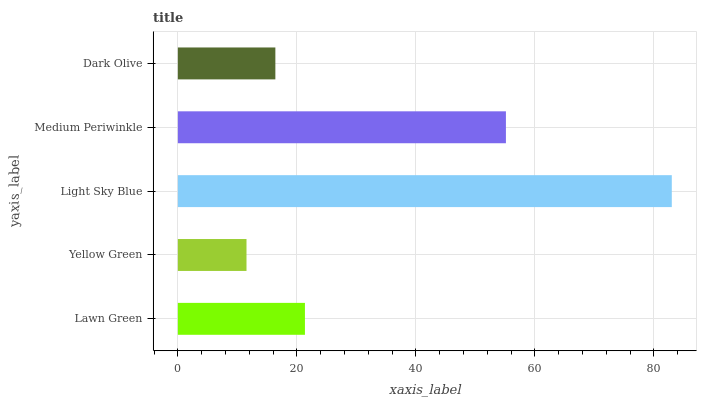Is Yellow Green the minimum?
Answer yes or no. Yes. Is Light Sky Blue the maximum?
Answer yes or no. Yes. Is Light Sky Blue the minimum?
Answer yes or no. No. Is Yellow Green the maximum?
Answer yes or no. No. Is Light Sky Blue greater than Yellow Green?
Answer yes or no. Yes. Is Yellow Green less than Light Sky Blue?
Answer yes or no. Yes. Is Yellow Green greater than Light Sky Blue?
Answer yes or no. No. Is Light Sky Blue less than Yellow Green?
Answer yes or no. No. Is Lawn Green the high median?
Answer yes or no. Yes. Is Lawn Green the low median?
Answer yes or no. Yes. Is Yellow Green the high median?
Answer yes or no. No. Is Light Sky Blue the low median?
Answer yes or no. No. 